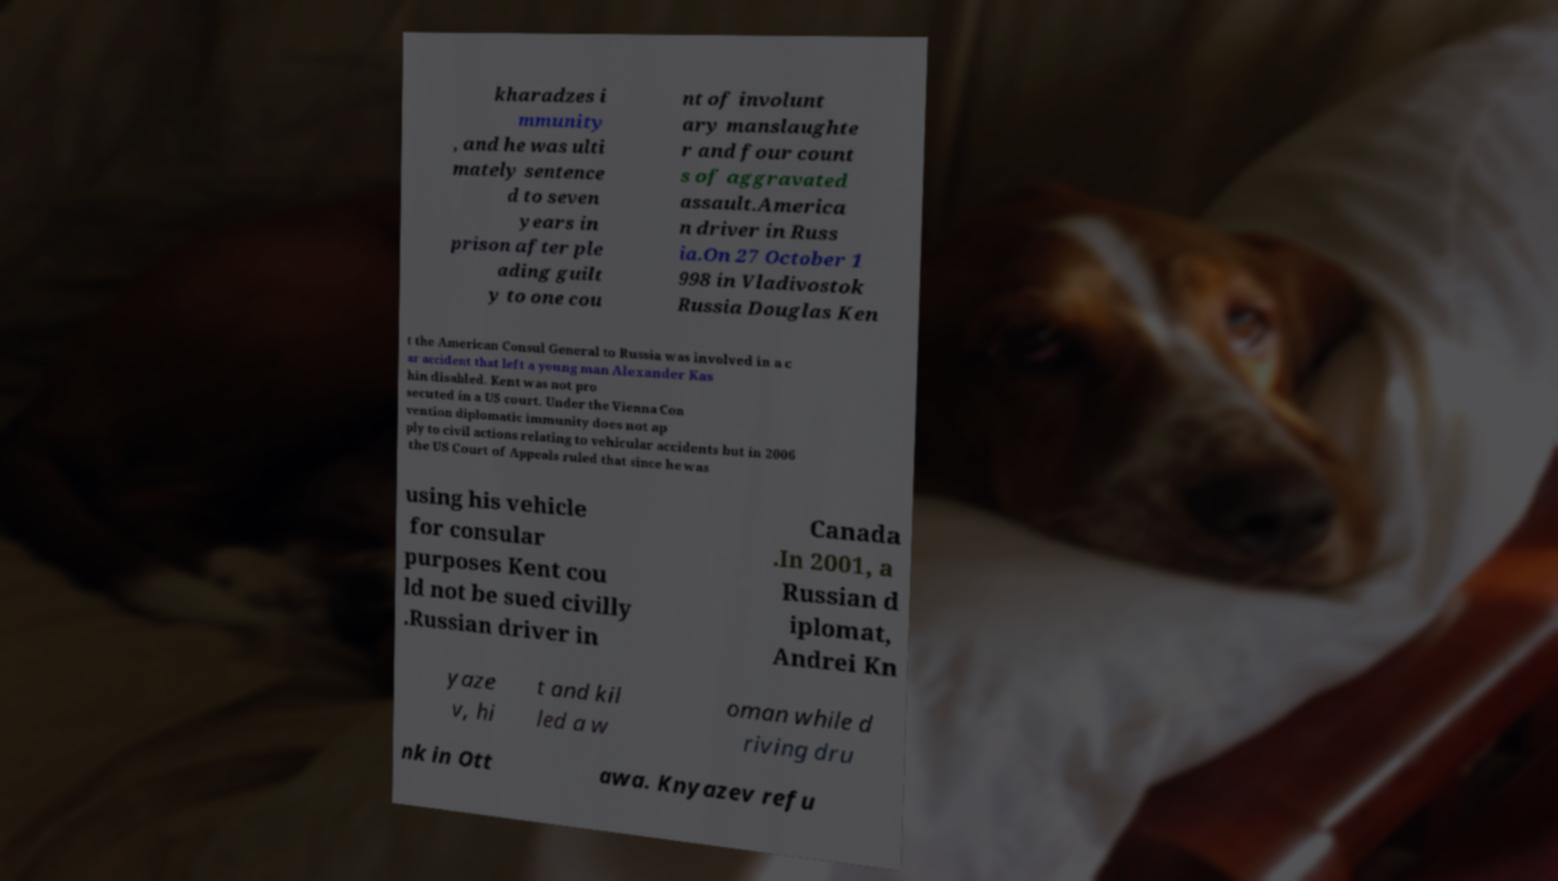Could you assist in decoding the text presented in this image and type it out clearly? kharadzes i mmunity , and he was ulti mately sentence d to seven years in prison after ple ading guilt y to one cou nt of involunt ary manslaughte r and four count s of aggravated assault.America n driver in Russ ia.On 27 October 1 998 in Vladivostok Russia Douglas Ken t the American Consul General to Russia was involved in a c ar accident that left a young man Alexander Kas hin disabled. Kent was not pro secuted in a US court. Under the Vienna Con vention diplomatic immunity does not ap ply to civil actions relating to vehicular accidents but in 2006 the US Court of Appeals ruled that since he was using his vehicle for consular purposes Kent cou ld not be sued civilly .Russian driver in Canada .In 2001, a Russian d iplomat, Andrei Kn yaze v, hi t and kil led a w oman while d riving dru nk in Ott awa. Knyazev refu 